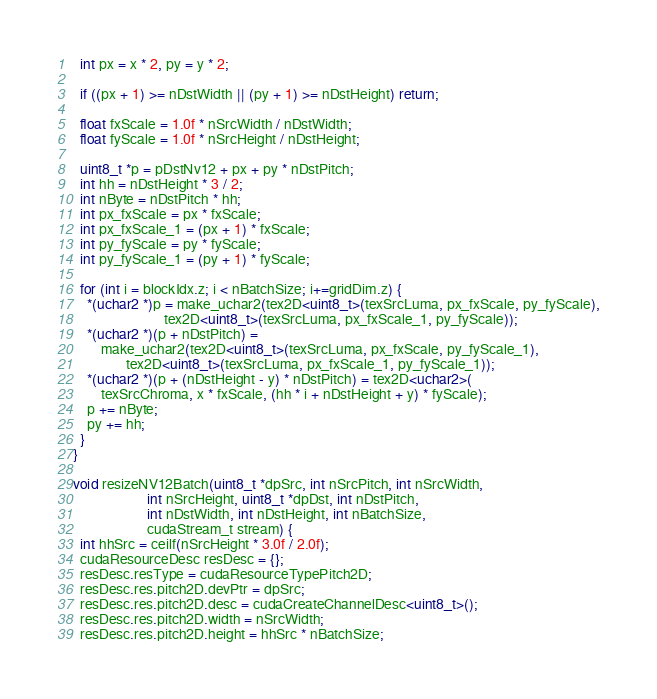<code> <loc_0><loc_0><loc_500><loc_500><_Cuda_>
  int px = x * 2, py = y * 2;

  if ((px + 1) >= nDstWidth || (py + 1) >= nDstHeight) return;

  float fxScale = 1.0f * nSrcWidth / nDstWidth;
  float fyScale = 1.0f * nSrcHeight / nDstHeight;

  uint8_t *p = pDstNv12 + px + py * nDstPitch;
  int hh = nDstHeight * 3 / 2;
  int nByte = nDstPitch * hh;
  int px_fxScale = px * fxScale;
  int px_fxScale_1 = (px + 1) * fxScale;
  int py_fyScale = py * fyScale;
  int py_fyScale_1 = (py + 1) * fyScale;

  for (int i = blockIdx.z; i < nBatchSize; i+=gridDim.z) {
    *(uchar2 *)p = make_uchar2(tex2D<uint8_t>(texSrcLuma, px_fxScale, py_fyScale),
                          tex2D<uint8_t>(texSrcLuma, px_fxScale_1, py_fyScale));
    *(uchar2 *)(p + nDstPitch) =
        make_uchar2(tex2D<uint8_t>(texSrcLuma, px_fxScale, py_fyScale_1),
               tex2D<uint8_t>(texSrcLuma, px_fxScale_1, py_fyScale_1));
    *(uchar2 *)(p + (nDstHeight - y) * nDstPitch) = tex2D<uchar2>(
        texSrcChroma, x * fxScale, (hh * i + nDstHeight + y) * fyScale);
    p += nByte;
    py += hh;
  }
}

void resizeNV12Batch(uint8_t *dpSrc, int nSrcPitch, int nSrcWidth,
                     int nSrcHeight, uint8_t *dpDst, int nDstPitch,
                     int nDstWidth, int nDstHeight, int nBatchSize,
                     cudaStream_t stream) {
  int hhSrc = ceilf(nSrcHeight * 3.0f / 2.0f);
  cudaResourceDesc resDesc = {};
  resDesc.resType = cudaResourceTypePitch2D;
  resDesc.res.pitch2D.devPtr = dpSrc;
  resDesc.res.pitch2D.desc = cudaCreateChannelDesc<uint8_t>();
  resDesc.res.pitch2D.width = nSrcWidth;
  resDesc.res.pitch2D.height = hhSrc * nBatchSize;</code> 